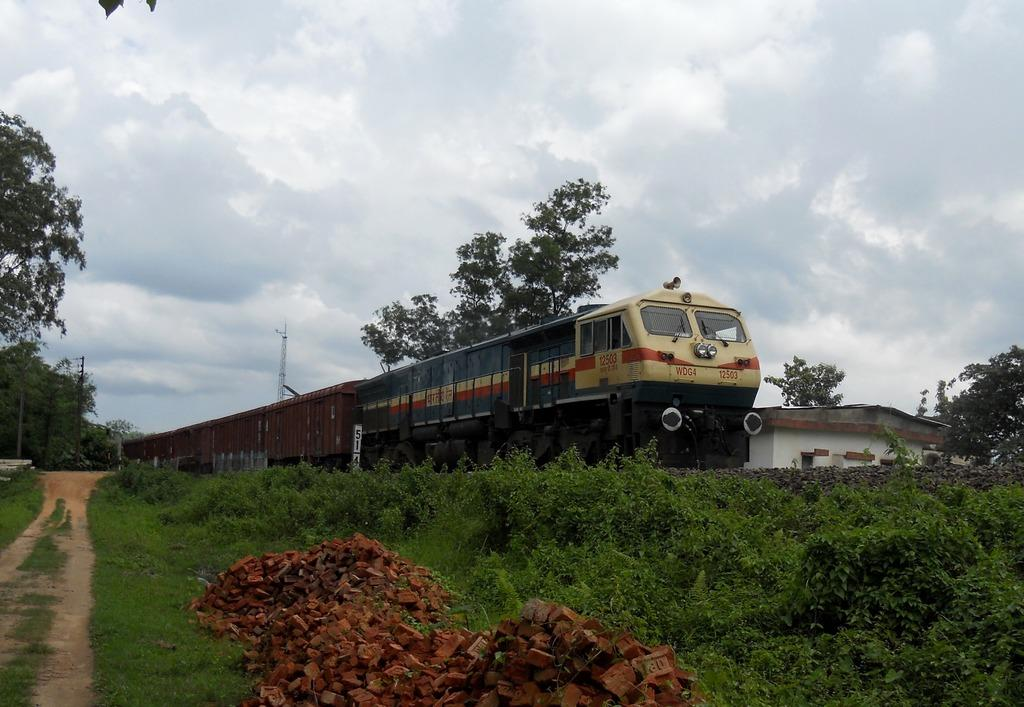What type of structure is visible in the image? There is a house in the image. What mode of transportation can be seen in the image? There is a train in the image. What type of vegetation is present in the image? There are trees and plants in the image. What type of objects are present in the image? There are poles and brick pieces at the bottom of the image. What is the condition of the sky in the image? The sky is cloudy in the image. Can you tell me how many bananas are hanging from the poles in the image? There are no bananas present in the image; only poles and brick pieces are visible. What type of lock is used to secure the train in the image? There is no lock visible in the image; the train is not secured. 